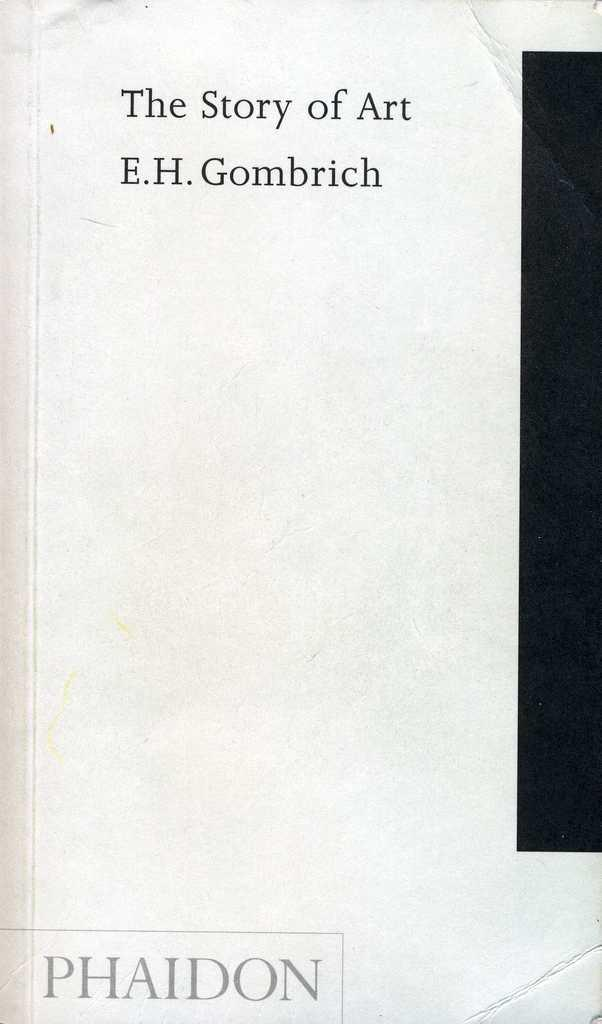What is the main subject of the image? The image contains a cover page of a book. Can you describe the cover page in the image? Unfortunately, the details of the cover page cannot be determined from the image alone. What type of wood is used to make the wine glasses in the image? There are no wine glasses or any reference to wood in the image, as it only contains a cover page of a book. 